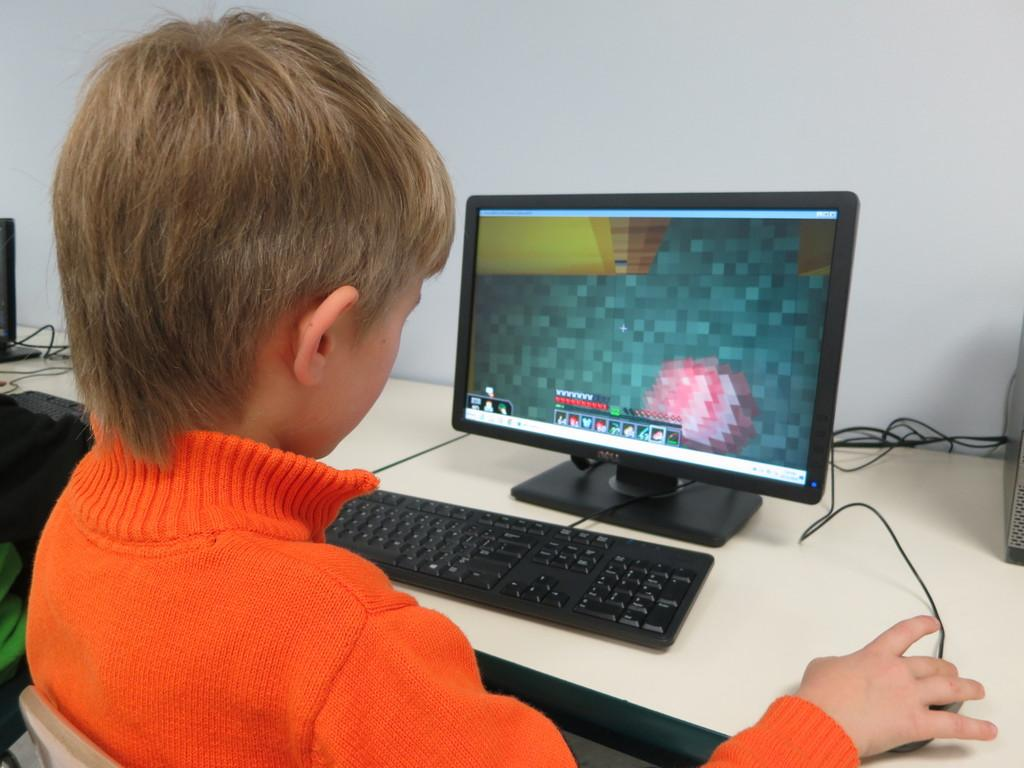<image>
Write a terse but informative summary of the picture. A young boy wearing orange is playing a game on a Dell computer. 